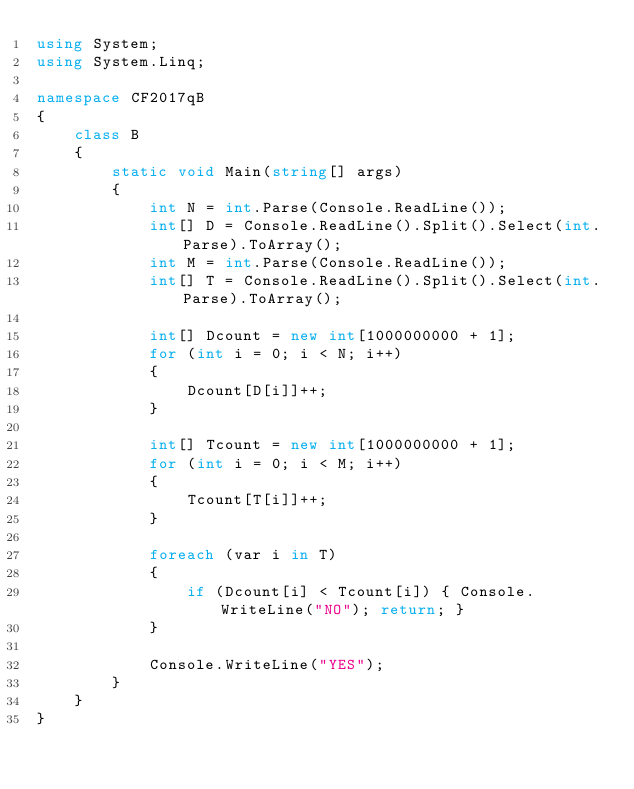Convert code to text. <code><loc_0><loc_0><loc_500><loc_500><_C#_>using System;
using System.Linq;

namespace CF2017qB
{
    class B
    {
        static void Main(string[] args)
        {
            int N = int.Parse(Console.ReadLine());
            int[] D = Console.ReadLine().Split().Select(int.Parse).ToArray();
            int M = int.Parse(Console.ReadLine());
            int[] T = Console.ReadLine().Split().Select(int.Parse).ToArray();

            int[] Dcount = new int[1000000000 + 1];
            for (int i = 0; i < N; i++)
            {
                Dcount[D[i]]++;
            }

            int[] Tcount = new int[1000000000 + 1];
            for (int i = 0; i < M; i++)
            {
                Tcount[T[i]]++;
            }

            foreach (var i in T)
            {
                if (Dcount[i] < Tcount[i]) { Console.WriteLine("NO"); return; }
            }

            Console.WriteLine("YES");
        }
    }
}
</code> 